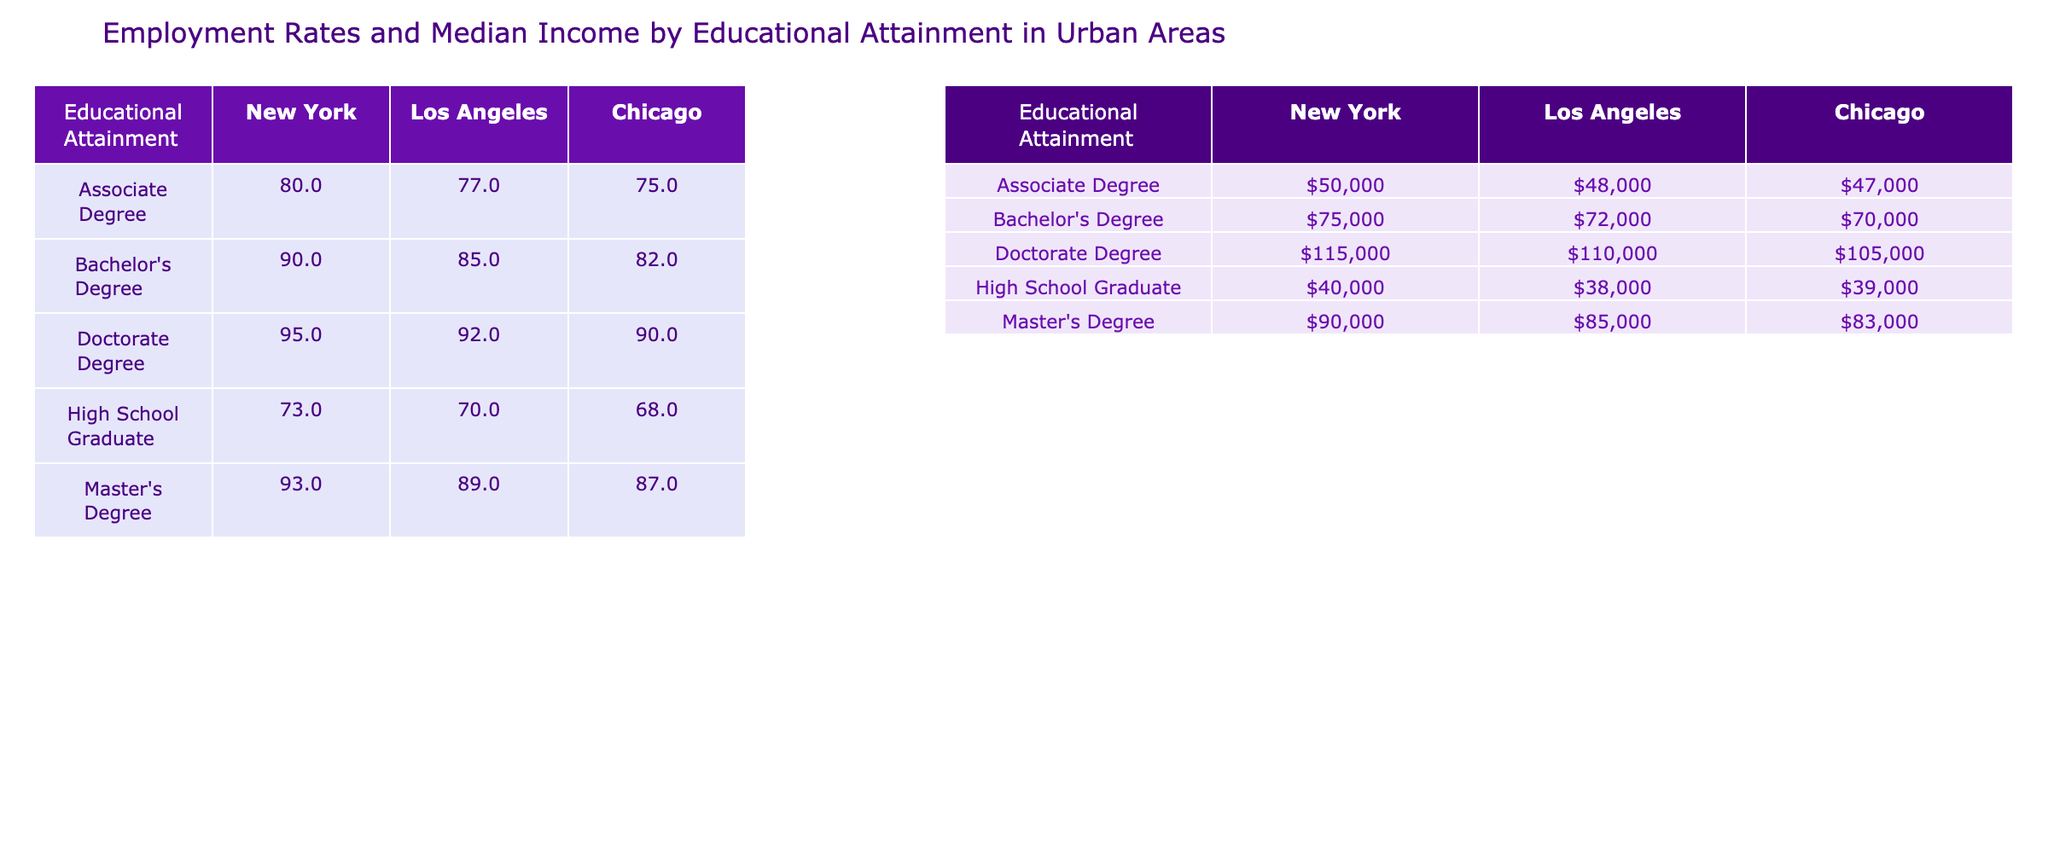What is the median income for individuals with a Bachelor's Degree in Chicago? Referring to the table, the median income for those with a Bachelor's Degree in Chicago is listed as $70,000.
Answer: $70,000 What is the employment rate for High School Graduates in Los Angeles? The table indicates the employment rate for High School Graduates in Los Angeles is 70%.
Answer: 70% Which city has the highest employment rate for individuals with an Associate Degree? According to the table, New York has the highest employment rate for those with an Associate Degree at 80%.
Answer: New York What is the difference in median income between Master's Degree holders in New York and Los Angeles? The median income for Master's Degree holders in New York is $90,000, while in Los Angeles it is $85,000. The difference is $90,000 - $85,000 = $5,000.
Answer: $5,000 Is the employment rate for individuals with a Doctorate Degree in Chicago higher than 90%? Looking at the table, the employment rate for Doctorate Degree holders in Chicago is 90%. Since 90% is not higher than 90%, the answer is no.
Answer: No What is the average median income for individuals with a Master's Degree across the three cities? The median incomes for Master's Degree holders are $90,000 (New York), $85,000 (Los Angeles), and $83,000 (Chicago). Summing these gives $90,000 + $85,000 + $83,000 = $258,000. Dividing by 3 gives an average of $86,000.
Answer: $86,000 Which group has the lowest employment rate overall? By examining the employment rates from the table, High School Graduates have the lowest employment rate at 68% in Chicago.
Answer: High School Graduates Which city has the highest median income for Associate Degree holders? The table shows that New York has the highest median income for Associate Degree holders at $50,000.
Answer: New York If the employment rate for Bachelor's Degree holders in Los Angeles increases by 3%, what would the new rate be? The current employment rate for Bachelor's Degree holders in Los Angeles is 85%. Therefore, if it increases by 3%, the new rate would be 85% + 3% = 88%.
Answer: 88% Are the median income levels for individuals with a Doctorate Degree higher in New York than in Chicago? The table lists the median income for Doctorate Degree holders as $115,000 in New York and $105,000 in Chicago. Since $115,000 is greater than $105,000, the answer is yes.
Answer: Yes 